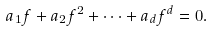<formula> <loc_0><loc_0><loc_500><loc_500>\ a _ { 1 } f + a _ { 2 } f ^ { 2 } + \dots + a _ { d } f ^ { d } = 0 .</formula> 